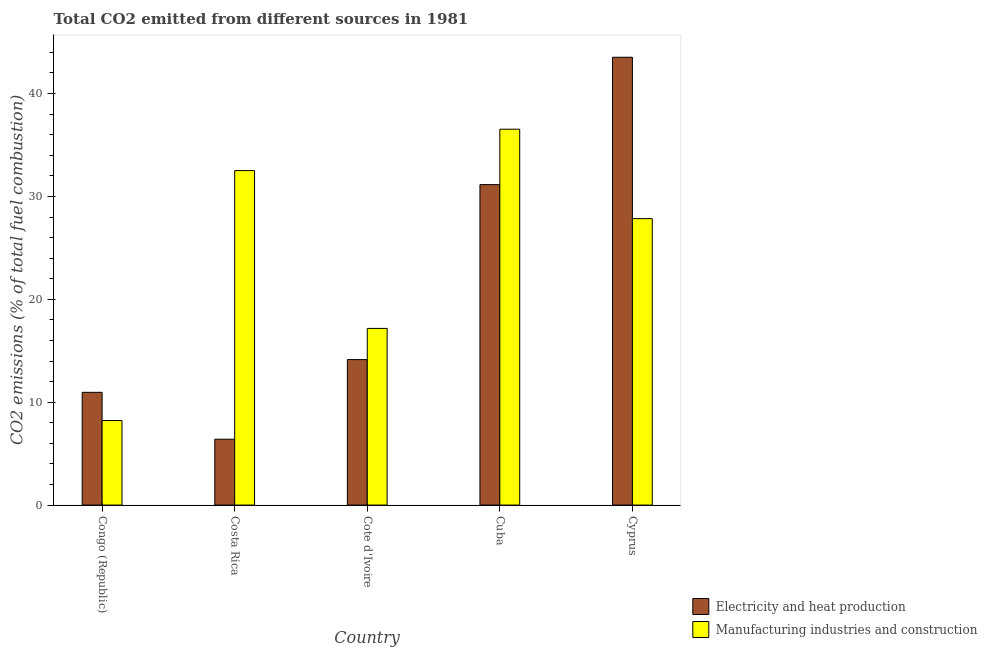How many groups of bars are there?
Provide a succinct answer. 5. Are the number of bars per tick equal to the number of legend labels?
Your response must be concise. Yes. Are the number of bars on each tick of the X-axis equal?
Offer a terse response. Yes. How many bars are there on the 1st tick from the left?
Make the answer very short. 2. How many bars are there on the 3rd tick from the right?
Give a very brief answer. 2. What is the label of the 1st group of bars from the left?
Provide a short and direct response. Congo (Republic). In how many cases, is the number of bars for a given country not equal to the number of legend labels?
Keep it short and to the point. 0. What is the co2 emissions due to electricity and heat production in Congo (Republic)?
Offer a terse response. 10.96. Across all countries, what is the maximum co2 emissions due to manufacturing industries?
Give a very brief answer. 36.54. Across all countries, what is the minimum co2 emissions due to manufacturing industries?
Offer a very short reply. 8.22. In which country was the co2 emissions due to electricity and heat production maximum?
Give a very brief answer. Cyprus. In which country was the co2 emissions due to manufacturing industries minimum?
Offer a very short reply. Congo (Republic). What is the total co2 emissions due to manufacturing industries in the graph?
Provide a succinct answer. 122.28. What is the difference between the co2 emissions due to manufacturing industries in Costa Rica and that in Cyprus?
Keep it short and to the point. 4.67. What is the difference between the co2 emissions due to manufacturing industries in Cuba and the co2 emissions due to electricity and heat production in Costa Rica?
Your answer should be compact. 30.13. What is the average co2 emissions due to manufacturing industries per country?
Provide a short and direct response. 24.46. What is the difference between the co2 emissions due to manufacturing industries and co2 emissions due to electricity and heat production in Cuba?
Give a very brief answer. 5.39. What is the ratio of the co2 emissions due to electricity and heat production in Congo (Republic) to that in Cuba?
Make the answer very short. 0.35. What is the difference between the highest and the second highest co2 emissions due to manufacturing industries?
Provide a short and direct response. 4.02. What is the difference between the highest and the lowest co2 emissions due to manufacturing industries?
Your answer should be very brief. 28.32. Is the sum of the co2 emissions due to electricity and heat production in Costa Rica and Cuba greater than the maximum co2 emissions due to manufacturing industries across all countries?
Make the answer very short. Yes. What does the 1st bar from the left in Cuba represents?
Provide a short and direct response. Electricity and heat production. What does the 2nd bar from the right in Cuba represents?
Provide a short and direct response. Electricity and heat production. How many bars are there?
Ensure brevity in your answer.  10. What is the difference between two consecutive major ticks on the Y-axis?
Your answer should be very brief. 10. What is the title of the graph?
Your answer should be compact. Total CO2 emitted from different sources in 1981. Does "Under-5(female)" appear as one of the legend labels in the graph?
Offer a terse response. No. What is the label or title of the X-axis?
Give a very brief answer. Country. What is the label or title of the Y-axis?
Make the answer very short. CO2 emissions (% of total fuel combustion). What is the CO2 emissions (% of total fuel combustion) in Electricity and heat production in Congo (Republic)?
Ensure brevity in your answer.  10.96. What is the CO2 emissions (% of total fuel combustion) in Manufacturing industries and construction in Congo (Republic)?
Keep it short and to the point. 8.22. What is the CO2 emissions (% of total fuel combustion) in Electricity and heat production in Costa Rica?
Your answer should be very brief. 6.4. What is the CO2 emissions (% of total fuel combustion) in Manufacturing industries and construction in Costa Rica?
Your response must be concise. 32.51. What is the CO2 emissions (% of total fuel combustion) of Electricity and heat production in Cote d'Ivoire?
Your response must be concise. 14.14. What is the CO2 emissions (% of total fuel combustion) of Manufacturing industries and construction in Cote d'Ivoire?
Offer a very short reply. 17.17. What is the CO2 emissions (% of total fuel combustion) in Electricity and heat production in Cuba?
Make the answer very short. 31.15. What is the CO2 emissions (% of total fuel combustion) in Manufacturing industries and construction in Cuba?
Give a very brief answer. 36.54. What is the CO2 emissions (% of total fuel combustion) of Electricity and heat production in Cyprus?
Your answer should be very brief. 43.53. What is the CO2 emissions (% of total fuel combustion) of Manufacturing industries and construction in Cyprus?
Your answer should be compact. 27.84. Across all countries, what is the maximum CO2 emissions (% of total fuel combustion) in Electricity and heat production?
Your answer should be compact. 43.53. Across all countries, what is the maximum CO2 emissions (% of total fuel combustion) in Manufacturing industries and construction?
Offer a very short reply. 36.54. Across all countries, what is the minimum CO2 emissions (% of total fuel combustion) of Electricity and heat production?
Ensure brevity in your answer.  6.4. Across all countries, what is the minimum CO2 emissions (% of total fuel combustion) in Manufacturing industries and construction?
Offer a terse response. 8.22. What is the total CO2 emissions (% of total fuel combustion) of Electricity and heat production in the graph?
Offer a terse response. 106.18. What is the total CO2 emissions (% of total fuel combustion) in Manufacturing industries and construction in the graph?
Ensure brevity in your answer.  122.28. What is the difference between the CO2 emissions (% of total fuel combustion) of Electricity and heat production in Congo (Republic) and that in Costa Rica?
Offer a very short reply. 4.55. What is the difference between the CO2 emissions (% of total fuel combustion) of Manufacturing industries and construction in Congo (Republic) and that in Costa Rica?
Make the answer very short. -24.29. What is the difference between the CO2 emissions (% of total fuel combustion) in Electricity and heat production in Congo (Republic) and that in Cote d'Ivoire?
Provide a short and direct response. -3.18. What is the difference between the CO2 emissions (% of total fuel combustion) of Manufacturing industries and construction in Congo (Republic) and that in Cote d'Ivoire?
Provide a short and direct response. -8.95. What is the difference between the CO2 emissions (% of total fuel combustion) in Electricity and heat production in Congo (Republic) and that in Cuba?
Make the answer very short. -20.19. What is the difference between the CO2 emissions (% of total fuel combustion) in Manufacturing industries and construction in Congo (Republic) and that in Cuba?
Make the answer very short. -28.32. What is the difference between the CO2 emissions (% of total fuel combustion) in Electricity and heat production in Congo (Republic) and that in Cyprus?
Your answer should be compact. -32.57. What is the difference between the CO2 emissions (% of total fuel combustion) of Manufacturing industries and construction in Congo (Republic) and that in Cyprus?
Offer a very short reply. -19.62. What is the difference between the CO2 emissions (% of total fuel combustion) in Electricity and heat production in Costa Rica and that in Cote d'Ivoire?
Make the answer very short. -7.74. What is the difference between the CO2 emissions (% of total fuel combustion) of Manufacturing industries and construction in Costa Rica and that in Cote d'Ivoire?
Your response must be concise. 15.34. What is the difference between the CO2 emissions (% of total fuel combustion) in Electricity and heat production in Costa Rica and that in Cuba?
Give a very brief answer. -24.75. What is the difference between the CO2 emissions (% of total fuel combustion) in Manufacturing industries and construction in Costa Rica and that in Cuba?
Your response must be concise. -4.02. What is the difference between the CO2 emissions (% of total fuel combustion) in Electricity and heat production in Costa Rica and that in Cyprus?
Keep it short and to the point. -37.13. What is the difference between the CO2 emissions (% of total fuel combustion) in Manufacturing industries and construction in Costa Rica and that in Cyprus?
Keep it short and to the point. 4.67. What is the difference between the CO2 emissions (% of total fuel combustion) of Electricity and heat production in Cote d'Ivoire and that in Cuba?
Provide a short and direct response. -17.01. What is the difference between the CO2 emissions (% of total fuel combustion) in Manufacturing industries and construction in Cote d'Ivoire and that in Cuba?
Provide a succinct answer. -19.36. What is the difference between the CO2 emissions (% of total fuel combustion) in Electricity and heat production in Cote d'Ivoire and that in Cyprus?
Offer a terse response. -29.39. What is the difference between the CO2 emissions (% of total fuel combustion) in Manufacturing industries and construction in Cote d'Ivoire and that in Cyprus?
Make the answer very short. -10.67. What is the difference between the CO2 emissions (% of total fuel combustion) in Electricity and heat production in Cuba and that in Cyprus?
Offer a very short reply. -12.38. What is the difference between the CO2 emissions (% of total fuel combustion) in Manufacturing industries and construction in Cuba and that in Cyprus?
Ensure brevity in your answer.  8.69. What is the difference between the CO2 emissions (% of total fuel combustion) of Electricity and heat production in Congo (Republic) and the CO2 emissions (% of total fuel combustion) of Manufacturing industries and construction in Costa Rica?
Offer a very short reply. -21.55. What is the difference between the CO2 emissions (% of total fuel combustion) of Electricity and heat production in Congo (Republic) and the CO2 emissions (% of total fuel combustion) of Manufacturing industries and construction in Cote d'Ivoire?
Provide a succinct answer. -6.21. What is the difference between the CO2 emissions (% of total fuel combustion) in Electricity and heat production in Congo (Republic) and the CO2 emissions (% of total fuel combustion) in Manufacturing industries and construction in Cuba?
Give a very brief answer. -25.58. What is the difference between the CO2 emissions (% of total fuel combustion) in Electricity and heat production in Congo (Republic) and the CO2 emissions (% of total fuel combustion) in Manufacturing industries and construction in Cyprus?
Your answer should be compact. -16.88. What is the difference between the CO2 emissions (% of total fuel combustion) of Electricity and heat production in Costa Rica and the CO2 emissions (% of total fuel combustion) of Manufacturing industries and construction in Cote d'Ivoire?
Offer a very short reply. -10.77. What is the difference between the CO2 emissions (% of total fuel combustion) in Electricity and heat production in Costa Rica and the CO2 emissions (% of total fuel combustion) in Manufacturing industries and construction in Cuba?
Provide a succinct answer. -30.13. What is the difference between the CO2 emissions (% of total fuel combustion) of Electricity and heat production in Costa Rica and the CO2 emissions (% of total fuel combustion) of Manufacturing industries and construction in Cyprus?
Offer a terse response. -21.44. What is the difference between the CO2 emissions (% of total fuel combustion) of Electricity and heat production in Cote d'Ivoire and the CO2 emissions (% of total fuel combustion) of Manufacturing industries and construction in Cuba?
Your answer should be very brief. -22.39. What is the difference between the CO2 emissions (% of total fuel combustion) of Electricity and heat production in Cote d'Ivoire and the CO2 emissions (% of total fuel combustion) of Manufacturing industries and construction in Cyprus?
Provide a succinct answer. -13.7. What is the difference between the CO2 emissions (% of total fuel combustion) in Electricity and heat production in Cuba and the CO2 emissions (% of total fuel combustion) in Manufacturing industries and construction in Cyprus?
Your answer should be very brief. 3.31. What is the average CO2 emissions (% of total fuel combustion) of Electricity and heat production per country?
Provide a short and direct response. 21.24. What is the average CO2 emissions (% of total fuel combustion) in Manufacturing industries and construction per country?
Your response must be concise. 24.46. What is the difference between the CO2 emissions (% of total fuel combustion) in Electricity and heat production and CO2 emissions (% of total fuel combustion) in Manufacturing industries and construction in Congo (Republic)?
Keep it short and to the point. 2.74. What is the difference between the CO2 emissions (% of total fuel combustion) in Electricity and heat production and CO2 emissions (% of total fuel combustion) in Manufacturing industries and construction in Costa Rica?
Give a very brief answer. -26.11. What is the difference between the CO2 emissions (% of total fuel combustion) in Electricity and heat production and CO2 emissions (% of total fuel combustion) in Manufacturing industries and construction in Cote d'Ivoire?
Provide a succinct answer. -3.03. What is the difference between the CO2 emissions (% of total fuel combustion) of Electricity and heat production and CO2 emissions (% of total fuel combustion) of Manufacturing industries and construction in Cuba?
Keep it short and to the point. -5.39. What is the difference between the CO2 emissions (% of total fuel combustion) of Electricity and heat production and CO2 emissions (% of total fuel combustion) of Manufacturing industries and construction in Cyprus?
Your answer should be very brief. 15.69. What is the ratio of the CO2 emissions (% of total fuel combustion) of Electricity and heat production in Congo (Republic) to that in Costa Rica?
Your answer should be compact. 1.71. What is the ratio of the CO2 emissions (% of total fuel combustion) of Manufacturing industries and construction in Congo (Republic) to that in Costa Rica?
Your answer should be compact. 0.25. What is the ratio of the CO2 emissions (% of total fuel combustion) of Electricity and heat production in Congo (Republic) to that in Cote d'Ivoire?
Keep it short and to the point. 0.78. What is the ratio of the CO2 emissions (% of total fuel combustion) of Manufacturing industries and construction in Congo (Republic) to that in Cote d'Ivoire?
Make the answer very short. 0.48. What is the ratio of the CO2 emissions (% of total fuel combustion) in Electricity and heat production in Congo (Republic) to that in Cuba?
Keep it short and to the point. 0.35. What is the ratio of the CO2 emissions (% of total fuel combustion) in Manufacturing industries and construction in Congo (Republic) to that in Cuba?
Give a very brief answer. 0.23. What is the ratio of the CO2 emissions (% of total fuel combustion) in Electricity and heat production in Congo (Republic) to that in Cyprus?
Your answer should be compact. 0.25. What is the ratio of the CO2 emissions (% of total fuel combustion) of Manufacturing industries and construction in Congo (Republic) to that in Cyprus?
Offer a very short reply. 0.3. What is the ratio of the CO2 emissions (% of total fuel combustion) in Electricity and heat production in Costa Rica to that in Cote d'Ivoire?
Your answer should be compact. 0.45. What is the ratio of the CO2 emissions (% of total fuel combustion) in Manufacturing industries and construction in Costa Rica to that in Cote d'Ivoire?
Your answer should be very brief. 1.89. What is the ratio of the CO2 emissions (% of total fuel combustion) in Electricity and heat production in Costa Rica to that in Cuba?
Give a very brief answer. 0.21. What is the ratio of the CO2 emissions (% of total fuel combustion) in Manufacturing industries and construction in Costa Rica to that in Cuba?
Provide a succinct answer. 0.89. What is the ratio of the CO2 emissions (% of total fuel combustion) in Electricity and heat production in Costa Rica to that in Cyprus?
Offer a very short reply. 0.15. What is the ratio of the CO2 emissions (% of total fuel combustion) of Manufacturing industries and construction in Costa Rica to that in Cyprus?
Offer a very short reply. 1.17. What is the ratio of the CO2 emissions (% of total fuel combustion) of Electricity and heat production in Cote d'Ivoire to that in Cuba?
Keep it short and to the point. 0.45. What is the ratio of the CO2 emissions (% of total fuel combustion) of Manufacturing industries and construction in Cote d'Ivoire to that in Cuba?
Give a very brief answer. 0.47. What is the ratio of the CO2 emissions (% of total fuel combustion) in Electricity and heat production in Cote d'Ivoire to that in Cyprus?
Make the answer very short. 0.32. What is the ratio of the CO2 emissions (% of total fuel combustion) of Manufacturing industries and construction in Cote d'Ivoire to that in Cyprus?
Provide a short and direct response. 0.62. What is the ratio of the CO2 emissions (% of total fuel combustion) in Electricity and heat production in Cuba to that in Cyprus?
Offer a very short reply. 0.72. What is the ratio of the CO2 emissions (% of total fuel combustion) in Manufacturing industries and construction in Cuba to that in Cyprus?
Provide a short and direct response. 1.31. What is the difference between the highest and the second highest CO2 emissions (% of total fuel combustion) in Electricity and heat production?
Provide a succinct answer. 12.38. What is the difference between the highest and the second highest CO2 emissions (% of total fuel combustion) of Manufacturing industries and construction?
Your answer should be compact. 4.02. What is the difference between the highest and the lowest CO2 emissions (% of total fuel combustion) of Electricity and heat production?
Provide a succinct answer. 37.13. What is the difference between the highest and the lowest CO2 emissions (% of total fuel combustion) of Manufacturing industries and construction?
Offer a terse response. 28.32. 